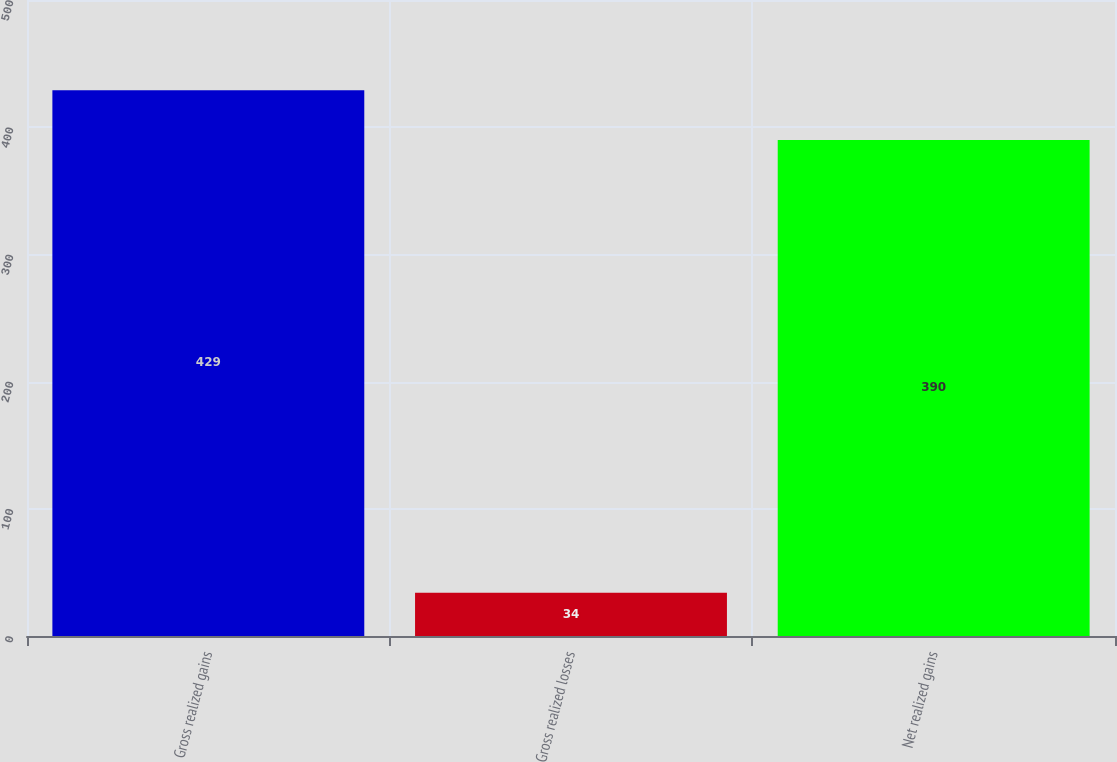Convert chart. <chart><loc_0><loc_0><loc_500><loc_500><bar_chart><fcel>Gross realized gains<fcel>Gross realized losses<fcel>Net realized gains<nl><fcel>429<fcel>34<fcel>390<nl></chart> 